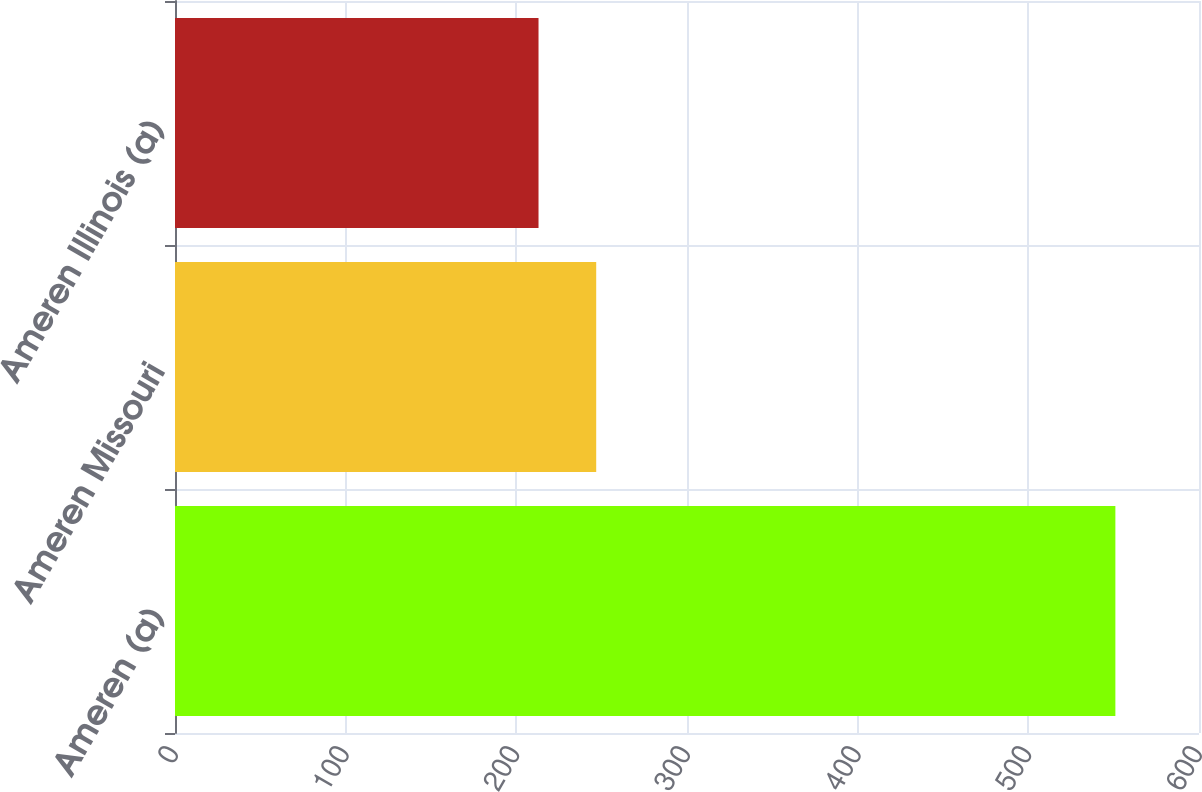Convert chart. <chart><loc_0><loc_0><loc_500><loc_500><bar_chart><fcel>Ameren (a)<fcel>Ameren Missouri<fcel>Ameren Illinois (a)<nl><fcel>551<fcel>246.8<fcel>213<nl></chart> 